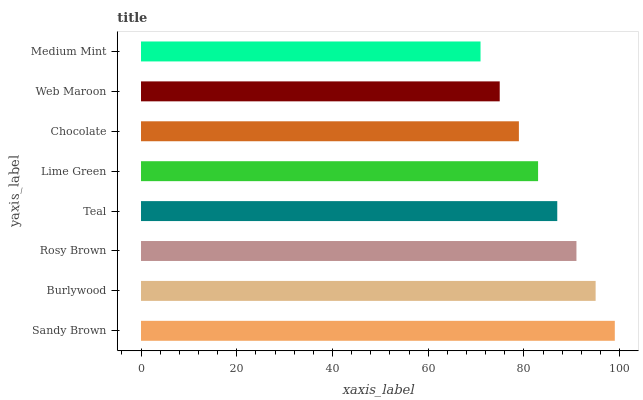Is Medium Mint the minimum?
Answer yes or no. Yes. Is Sandy Brown the maximum?
Answer yes or no. Yes. Is Burlywood the minimum?
Answer yes or no. No. Is Burlywood the maximum?
Answer yes or no. No. Is Sandy Brown greater than Burlywood?
Answer yes or no. Yes. Is Burlywood less than Sandy Brown?
Answer yes or no. Yes. Is Burlywood greater than Sandy Brown?
Answer yes or no. No. Is Sandy Brown less than Burlywood?
Answer yes or no. No. Is Teal the high median?
Answer yes or no. Yes. Is Lime Green the low median?
Answer yes or no. Yes. Is Medium Mint the high median?
Answer yes or no. No. Is Medium Mint the low median?
Answer yes or no. No. 